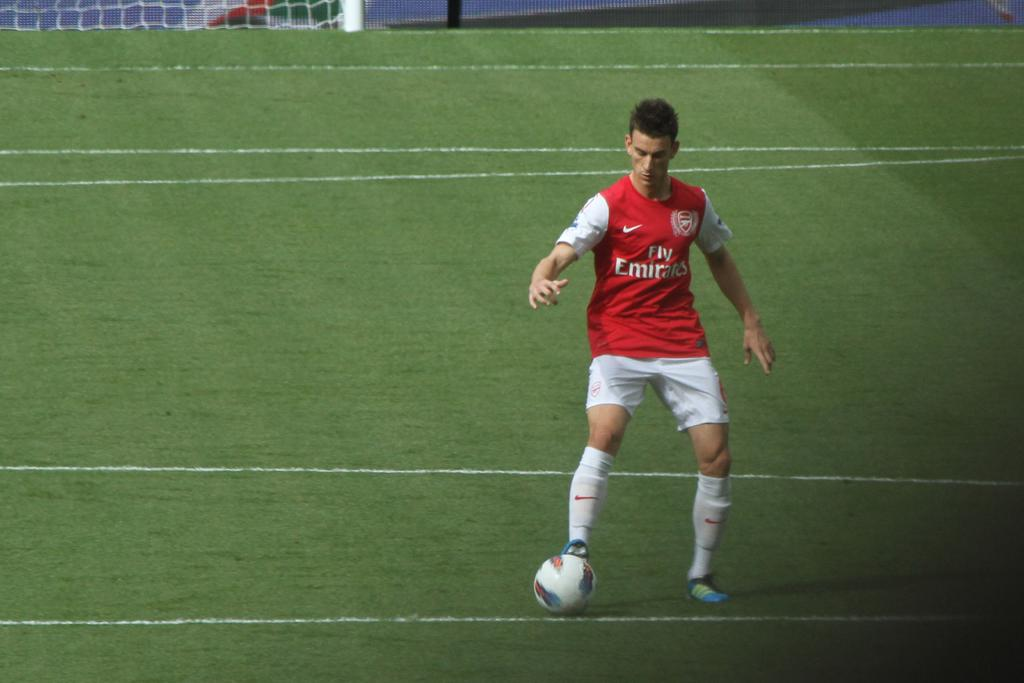What is the person in the image doing? The person is playing football. What type of clothing is the person wearing? The person is wearing a T-shirt and shorts. What is the surface of the ground in the image? The ground is covered with grass. What is the purpose of the net in the image? The net is likely used to catch or contain the football during the game. What is the color and purpose of the pole in the image? The pole is white-colored and may be used to support the net or mark a boundary in the game. What note is the person playing on the guitar in the image? There is no guitar present in the image; the person is playing football. How many friends is the person with in the image? The image only shows one person, so it cannot be determined how many friends are present. 